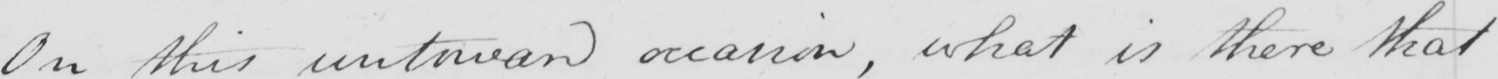Can you tell me what this handwritten text says? On this untoward occasion , what is there that 